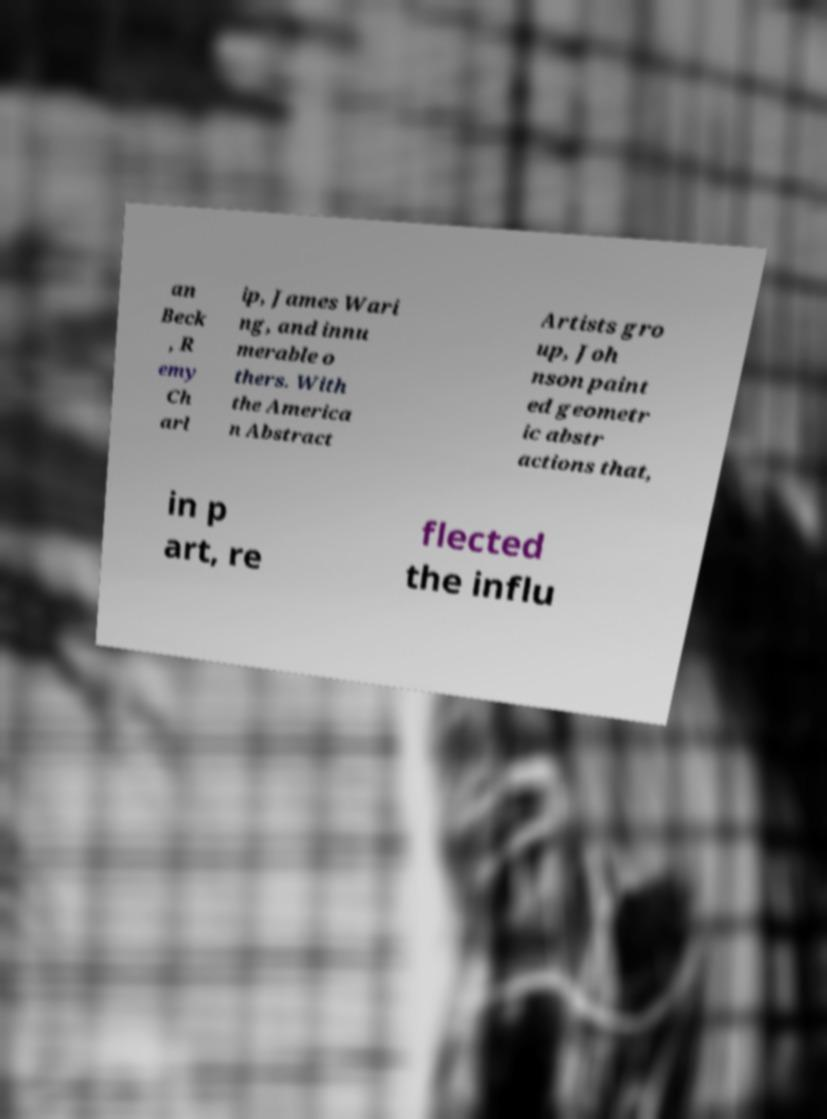Please identify and transcribe the text found in this image. an Beck , R emy Ch arl ip, James Wari ng, and innu merable o thers. With the America n Abstract Artists gro up, Joh nson paint ed geometr ic abstr actions that, in p art, re flected the influ 